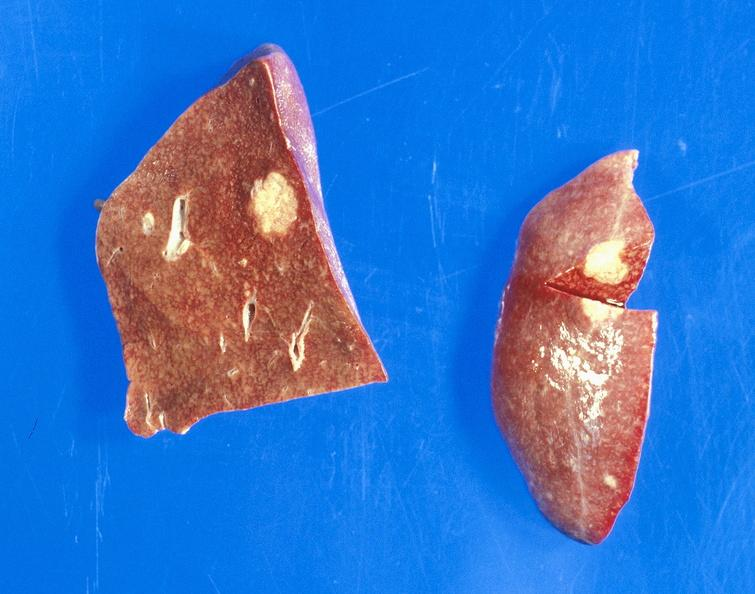s hepatobiliary present?
Answer the question using a single word or phrase. Yes 